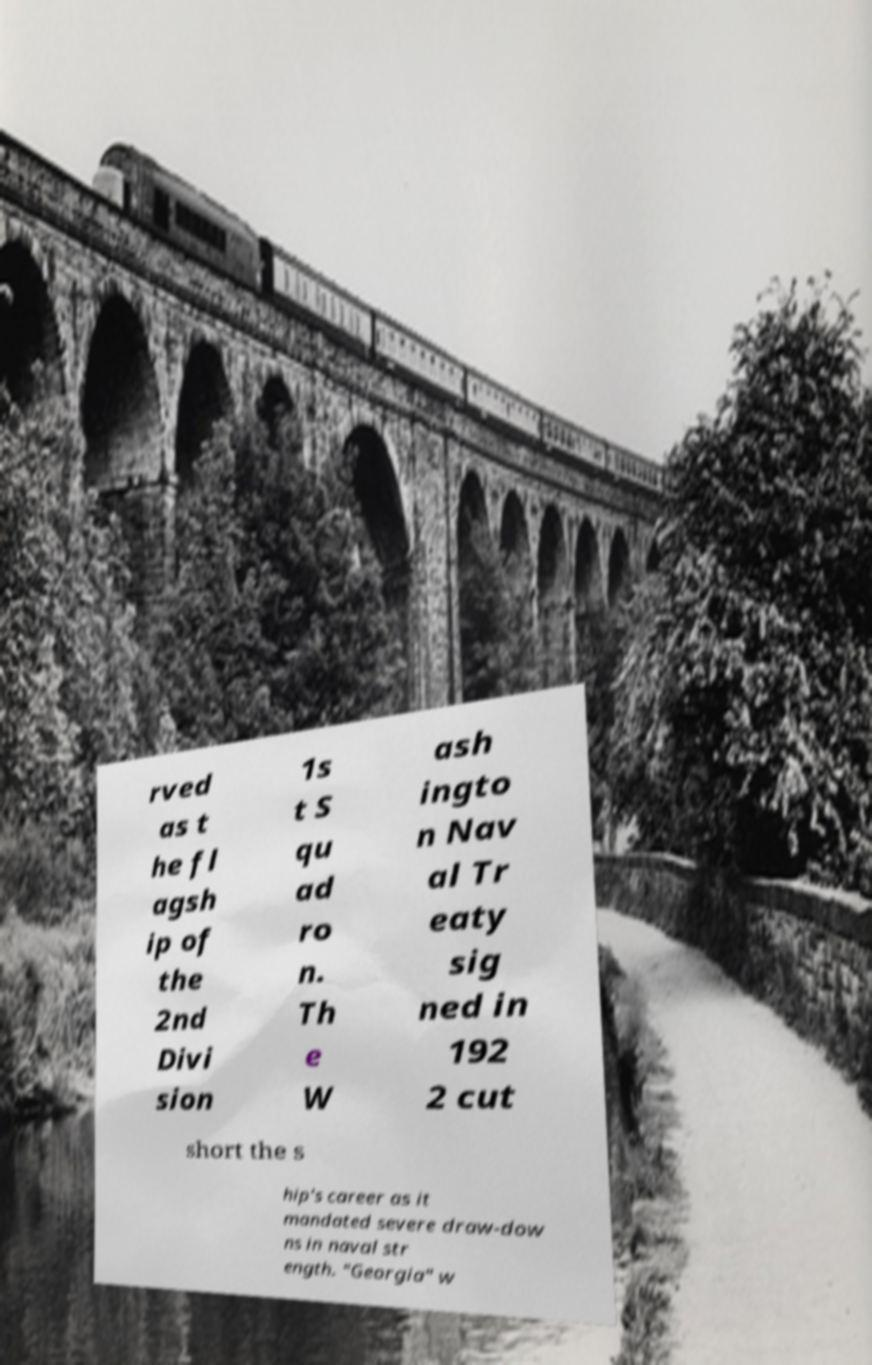Could you extract and type out the text from this image? rved as t he fl agsh ip of the 2nd Divi sion 1s t S qu ad ro n. Th e W ash ingto n Nav al Tr eaty sig ned in 192 2 cut short the s hip's career as it mandated severe draw-dow ns in naval str ength. "Georgia" w 